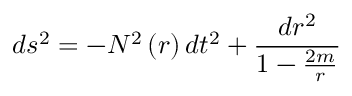<formula> <loc_0><loc_0><loc_500><loc_500>d s ^ { 2 } = - N ^ { 2 } \left ( r \right ) d t ^ { 2 } + \frac { d r ^ { 2 } } { 1 - \frac { 2 m } { r } }</formula> 